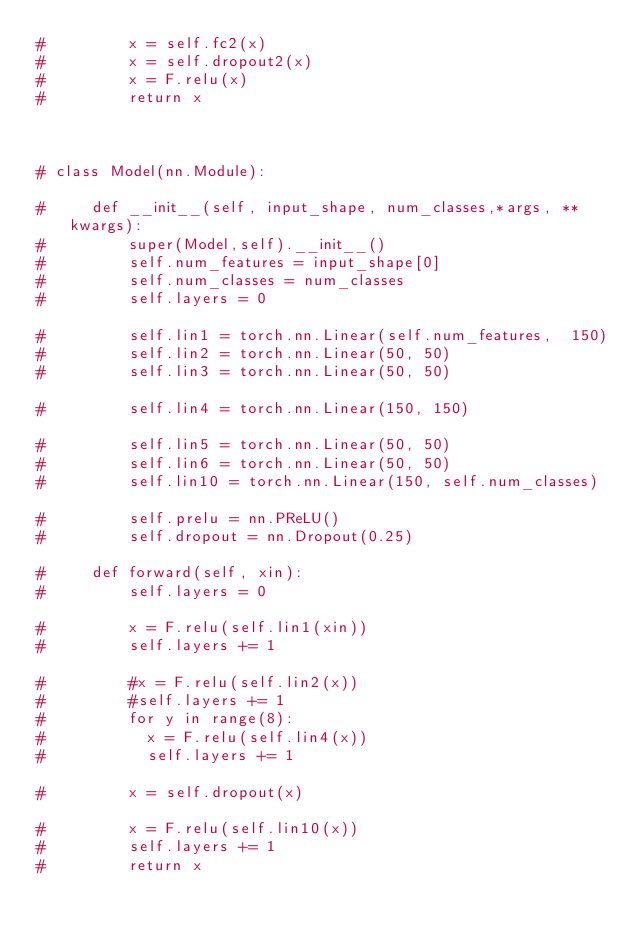Convert code to text. <code><loc_0><loc_0><loc_500><loc_500><_Python_>#         x = self.fc2(x)
#         x = self.dropout2(x)
#         x = F.relu(x)
#         return x

    

# class Model(nn.Module):
    
#     def __init__(self, input_shape, num_classes,*args, **kwargs):
#         super(Model,self).__init__()
#         self.num_features = input_shape[0]
#         self.num_classes = num_classes
#         self.layers = 0
        
#         self.lin1 = torch.nn.Linear(self.num_features,  150)        
#         self.lin2 = torch.nn.Linear(50, 50)        
#         self.lin3 = torch.nn.Linear(50, 50)
        
#         self.lin4 = torch.nn.Linear(150, 150) 
        
#         self.lin5 = torch.nn.Linear(50, 50)        
#         self.lin6 = torch.nn.Linear(50, 50)
#         self.lin10 = torch.nn.Linear(150, self.num_classes)
        
#         self.prelu = nn.PReLU()
#         self.dropout = nn.Dropout(0.25)

#     def forward(self, xin):
#         self.layers = 0
        
#         x = F.relu(self.lin1(xin))
#         self.layers += 1
        
#         #x = F.relu(self.lin2(x))
#         #self.layers += 1
#         for y in range(8):
#           x = F.relu(self.lin4(x)) 
#           self.layers += 1
           
#         x = self.dropout(x)
        
#         x = F.relu(self.lin10(x)) 
#         self.layers += 1
#         return x</code> 